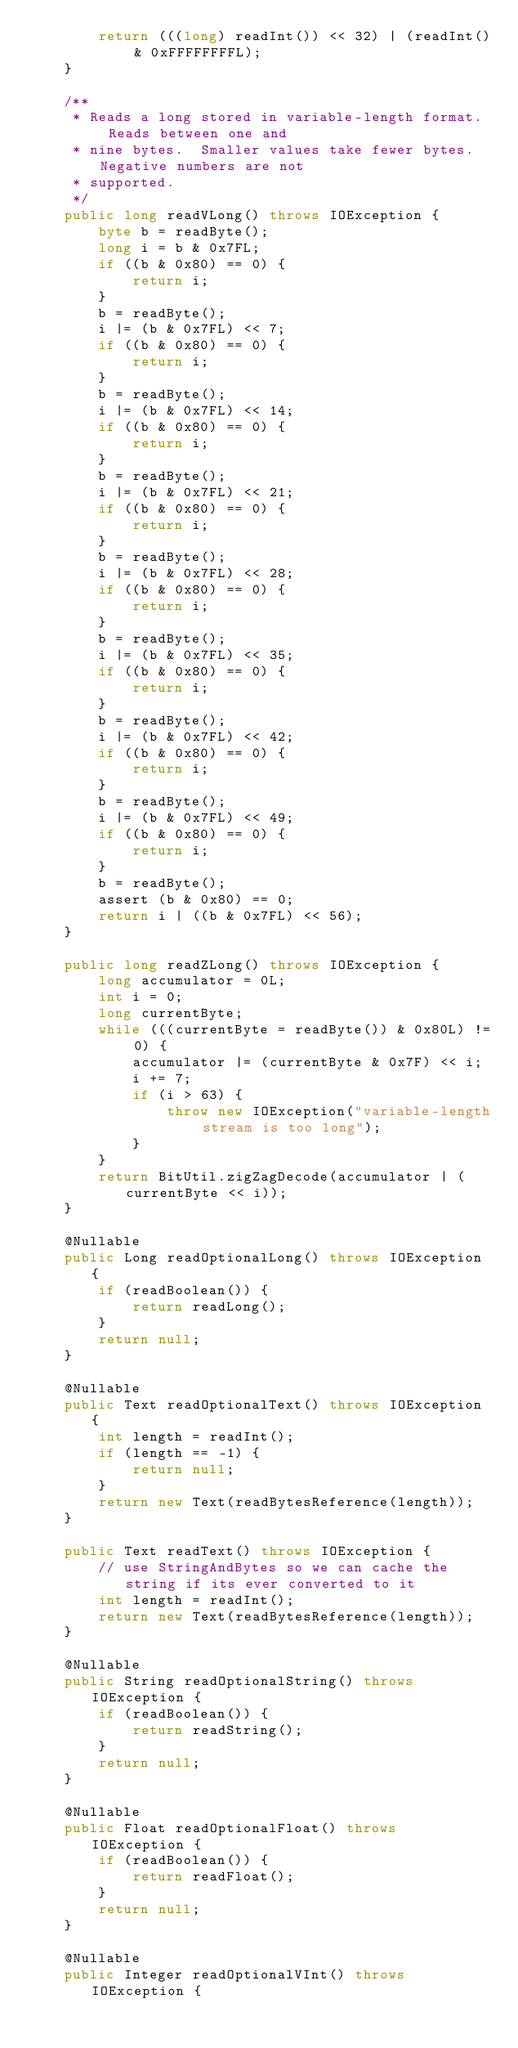<code> <loc_0><loc_0><loc_500><loc_500><_Java_>        return (((long) readInt()) << 32) | (readInt() & 0xFFFFFFFFL);
    }

    /**
     * Reads a long stored in variable-length format.  Reads between one and
     * nine bytes.  Smaller values take fewer bytes.  Negative numbers are not
     * supported.
     */
    public long readVLong() throws IOException {
        byte b = readByte();
        long i = b & 0x7FL;
        if ((b & 0x80) == 0) {
            return i;
        }
        b = readByte();
        i |= (b & 0x7FL) << 7;
        if ((b & 0x80) == 0) {
            return i;
        }
        b = readByte();
        i |= (b & 0x7FL) << 14;
        if ((b & 0x80) == 0) {
            return i;
        }
        b = readByte();
        i |= (b & 0x7FL) << 21;
        if ((b & 0x80) == 0) {
            return i;
        }
        b = readByte();
        i |= (b & 0x7FL) << 28;
        if ((b & 0x80) == 0) {
            return i;
        }
        b = readByte();
        i |= (b & 0x7FL) << 35;
        if ((b & 0x80) == 0) {
            return i;
        }
        b = readByte();
        i |= (b & 0x7FL) << 42;
        if ((b & 0x80) == 0) {
            return i;
        }
        b = readByte();
        i |= (b & 0x7FL) << 49;
        if ((b & 0x80) == 0) {
            return i;
        }
        b = readByte();
        assert (b & 0x80) == 0;
        return i | ((b & 0x7FL) << 56);
    }

    public long readZLong() throws IOException {
        long accumulator = 0L;
        int i = 0;
        long currentByte;
        while (((currentByte = readByte()) & 0x80L) != 0) {
            accumulator |= (currentByte & 0x7F) << i;
            i += 7;
            if (i > 63) {
                throw new IOException("variable-length stream is too long");
            }
        }
        return BitUtil.zigZagDecode(accumulator | (currentByte << i));
    }

    @Nullable
    public Long readOptionalLong() throws IOException {
        if (readBoolean()) {
            return readLong();
        }
        return null;
    }

    @Nullable
    public Text readOptionalText() throws IOException {
        int length = readInt();
        if (length == -1) {
            return null;
        }
        return new Text(readBytesReference(length));
    }

    public Text readText() throws IOException {
        // use StringAndBytes so we can cache the string if its ever converted to it
        int length = readInt();
        return new Text(readBytesReference(length));
    }

    @Nullable
    public String readOptionalString() throws IOException {
        if (readBoolean()) {
            return readString();
        }
        return null;
    }

    @Nullable
    public Float readOptionalFloat() throws IOException {
        if (readBoolean()) {
            return readFloat();
        }
        return null;
    }

    @Nullable
    public Integer readOptionalVInt() throws IOException {</code> 